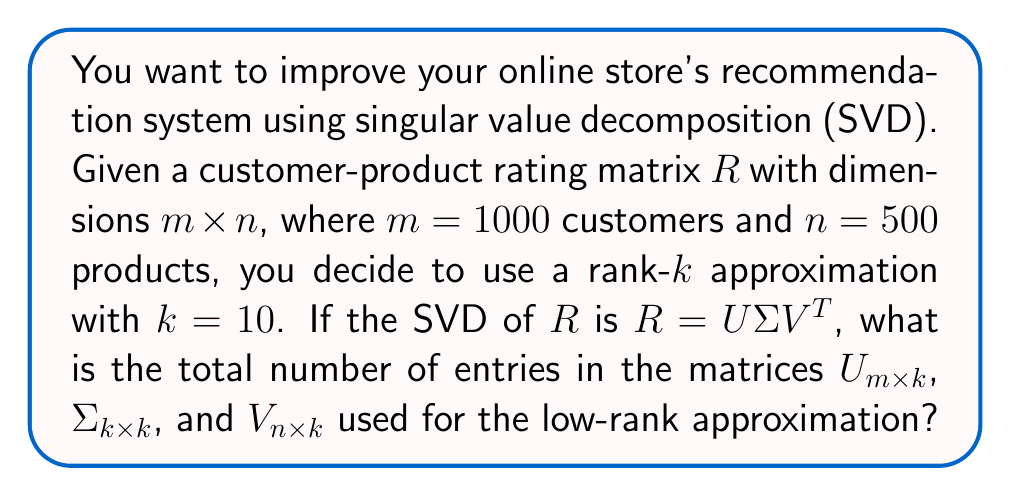Give your solution to this math problem. Let's break this down step-by-step:

1) In SVD, we have $R = U\Sigma V^T$, where:
   - $U$ is an $m \times m$ matrix
   - $\Sigma$ is an $m \times n$ diagonal matrix
   - $V^T$ is an $n \times n$ matrix

2) For a rank-$k$ approximation, we use:
   - $U_{m \times k}$: first $k$ columns of $U$
   - $\Sigma_{k \times k}$: top-left $k \times k$ submatrix of $\Sigma$
   - $V_{n \times k}$: first $k$ columns of $V$

3) Now, let's count the entries in each matrix:
   - $U_{m \times k}$: $m \times k = 1000 \times 10 = 10000$ entries
   - $\Sigma_{k \times k}$: $k \times k = 10 \times 10 = 100$ entries
   - $V_{n \times k}$: $n \times k = 500 \times 10 = 5000$ entries

4) Total number of entries:
   $10000 + 100 + 5000 = 15100$
Answer: 15100 